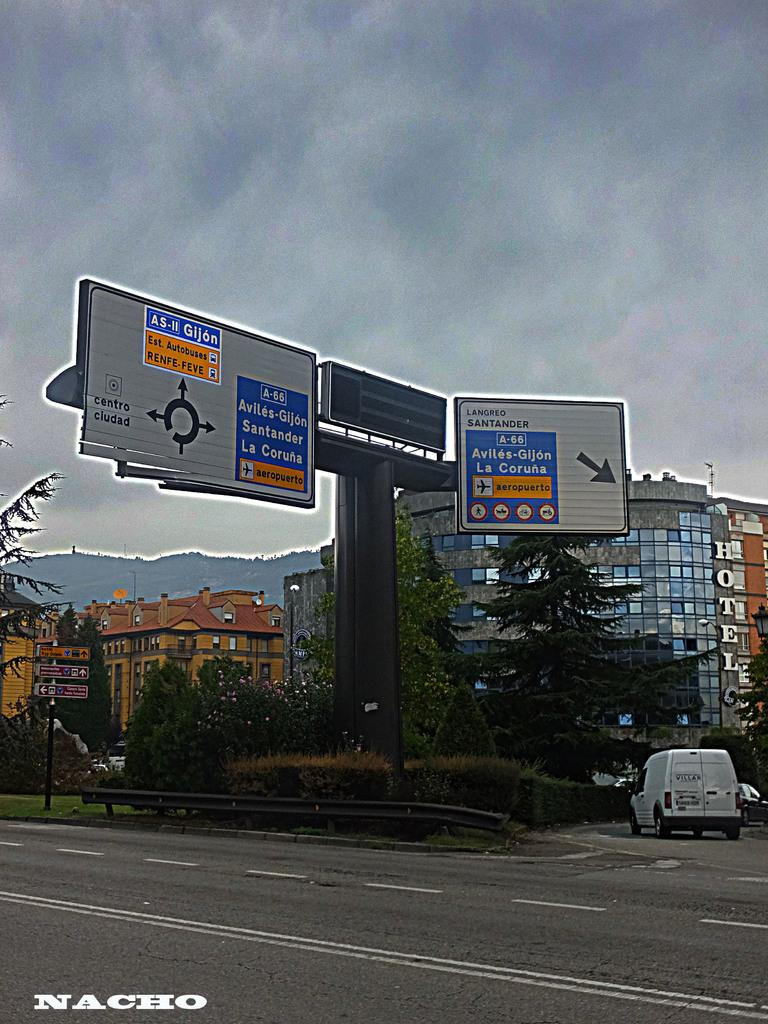<image>
Provide a brief description of the given image. The sign over a highway directs those going to La Coruna to get in the right lane. 